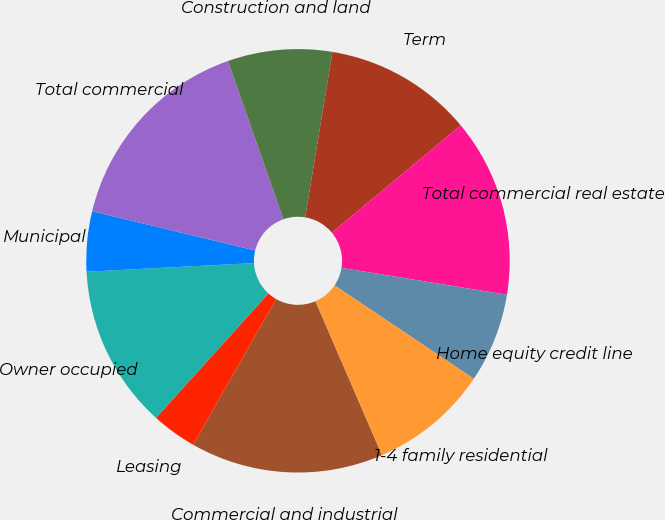Convert chart. <chart><loc_0><loc_0><loc_500><loc_500><pie_chart><fcel>Commercial and industrial<fcel>Leasing<fcel>Owner occupied<fcel>Municipal<fcel>Total commercial<fcel>Construction and land<fcel>Term<fcel>Total commercial real estate<fcel>Home equity credit line<fcel>1-4 family residential<nl><fcel>14.74%<fcel>3.45%<fcel>12.48%<fcel>4.58%<fcel>15.87%<fcel>7.97%<fcel>11.35%<fcel>13.61%<fcel>6.84%<fcel>9.1%<nl></chart> 